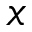<formula> <loc_0><loc_0><loc_500><loc_500>x</formula> 